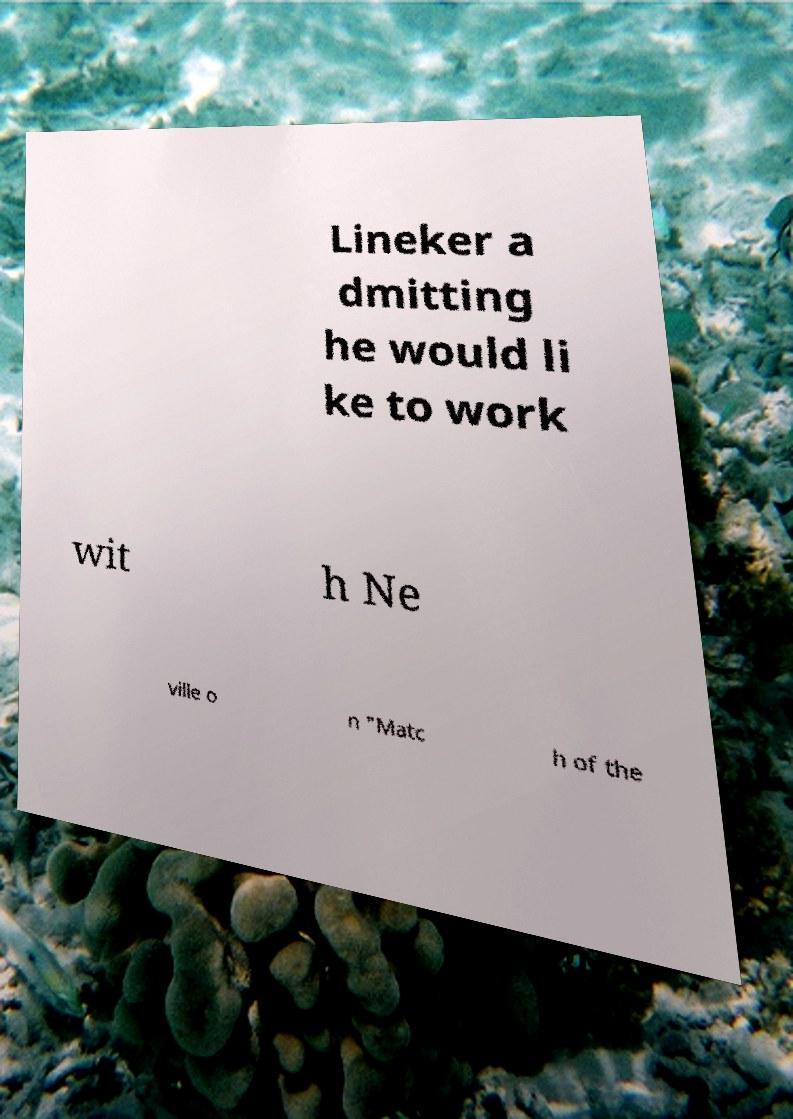I need the written content from this picture converted into text. Can you do that? Lineker a dmitting he would li ke to work wit h Ne ville o n "Matc h of the 